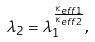Convert formula to latex. <formula><loc_0><loc_0><loc_500><loc_500>\lambda _ { 2 } = \lambda _ { 1 } ^ { \frac { \kappa _ { e f f 1 } } { \kappa _ { e f f 2 } } } ,</formula> 